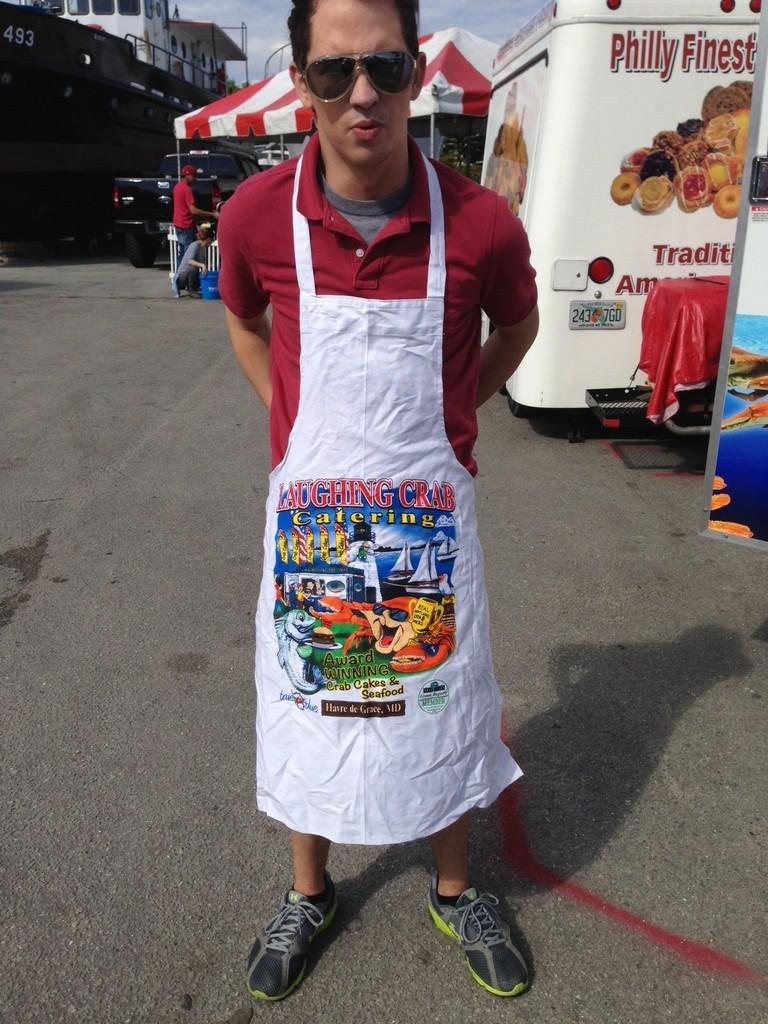Provide a one-sentence caption for the provided image. The owners of this catering company believe that crabs can laugh. 